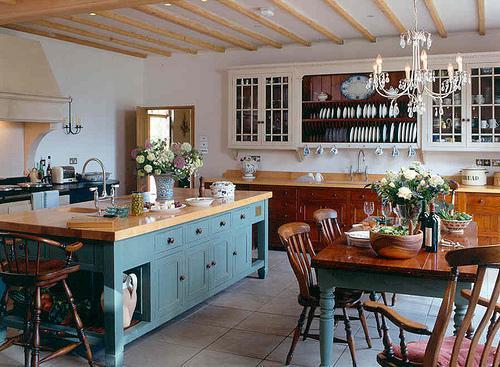How many legs does the stool have?
Give a very brief answer. 4. How many lights are on the chandelier?
Give a very brief answer. 6. How many knives are on the butcher block?
Give a very brief answer. 1. 